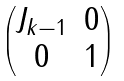<formula> <loc_0><loc_0><loc_500><loc_500>\begin{pmatrix} J _ { k - 1 } & 0 \\ 0 & 1 \end{pmatrix}</formula> 